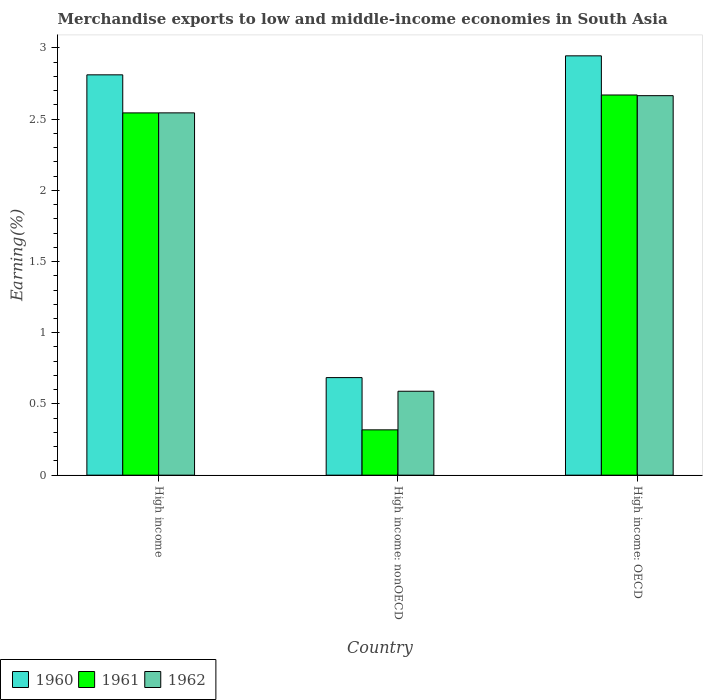How many groups of bars are there?
Your answer should be compact. 3. How many bars are there on the 2nd tick from the left?
Give a very brief answer. 3. How many bars are there on the 1st tick from the right?
Make the answer very short. 3. In how many cases, is the number of bars for a given country not equal to the number of legend labels?
Provide a short and direct response. 0. What is the percentage of amount earned from merchandise exports in 1960 in High income: nonOECD?
Make the answer very short. 0.69. Across all countries, what is the maximum percentage of amount earned from merchandise exports in 1960?
Give a very brief answer. 2.94. Across all countries, what is the minimum percentage of amount earned from merchandise exports in 1961?
Your response must be concise. 0.32. In which country was the percentage of amount earned from merchandise exports in 1960 maximum?
Provide a short and direct response. High income: OECD. In which country was the percentage of amount earned from merchandise exports in 1962 minimum?
Your answer should be compact. High income: nonOECD. What is the total percentage of amount earned from merchandise exports in 1962 in the graph?
Ensure brevity in your answer.  5.8. What is the difference between the percentage of amount earned from merchandise exports in 1962 in High income and that in High income: OECD?
Give a very brief answer. -0.12. What is the difference between the percentage of amount earned from merchandise exports in 1960 in High income and the percentage of amount earned from merchandise exports in 1961 in High income: OECD?
Ensure brevity in your answer.  0.14. What is the average percentage of amount earned from merchandise exports in 1962 per country?
Keep it short and to the point. 1.93. What is the difference between the percentage of amount earned from merchandise exports of/in 1962 and percentage of amount earned from merchandise exports of/in 1961 in High income: nonOECD?
Provide a succinct answer. 0.27. In how many countries, is the percentage of amount earned from merchandise exports in 1961 greater than 1 %?
Your response must be concise. 2. What is the ratio of the percentage of amount earned from merchandise exports in 1960 in High income: OECD to that in High income: nonOECD?
Your answer should be compact. 4.3. What is the difference between the highest and the second highest percentage of amount earned from merchandise exports in 1962?
Your answer should be very brief. -2.08. What is the difference between the highest and the lowest percentage of amount earned from merchandise exports in 1960?
Ensure brevity in your answer.  2.26. In how many countries, is the percentage of amount earned from merchandise exports in 1961 greater than the average percentage of amount earned from merchandise exports in 1961 taken over all countries?
Your answer should be very brief. 2. How many bars are there?
Offer a terse response. 9. Are all the bars in the graph horizontal?
Provide a short and direct response. No. Does the graph contain any zero values?
Keep it short and to the point. No. Does the graph contain grids?
Give a very brief answer. No. Where does the legend appear in the graph?
Offer a terse response. Bottom left. How many legend labels are there?
Your response must be concise. 3. What is the title of the graph?
Keep it short and to the point. Merchandise exports to low and middle-income economies in South Asia. What is the label or title of the Y-axis?
Give a very brief answer. Earning(%). What is the Earning(%) of 1960 in High income?
Provide a short and direct response. 2.81. What is the Earning(%) of 1961 in High income?
Provide a succinct answer. 2.54. What is the Earning(%) of 1962 in High income?
Ensure brevity in your answer.  2.54. What is the Earning(%) of 1960 in High income: nonOECD?
Offer a very short reply. 0.69. What is the Earning(%) in 1961 in High income: nonOECD?
Offer a very short reply. 0.32. What is the Earning(%) in 1962 in High income: nonOECD?
Offer a terse response. 0.59. What is the Earning(%) of 1960 in High income: OECD?
Provide a short and direct response. 2.94. What is the Earning(%) of 1961 in High income: OECD?
Provide a succinct answer. 2.67. What is the Earning(%) in 1962 in High income: OECD?
Your answer should be compact. 2.66. Across all countries, what is the maximum Earning(%) in 1960?
Provide a succinct answer. 2.94. Across all countries, what is the maximum Earning(%) of 1961?
Give a very brief answer. 2.67. Across all countries, what is the maximum Earning(%) of 1962?
Provide a succinct answer. 2.66. Across all countries, what is the minimum Earning(%) in 1960?
Provide a succinct answer. 0.69. Across all countries, what is the minimum Earning(%) in 1961?
Keep it short and to the point. 0.32. Across all countries, what is the minimum Earning(%) in 1962?
Provide a short and direct response. 0.59. What is the total Earning(%) in 1960 in the graph?
Your response must be concise. 6.44. What is the total Earning(%) of 1961 in the graph?
Your answer should be compact. 5.53. What is the total Earning(%) of 1962 in the graph?
Your answer should be very brief. 5.8. What is the difference between the Earning(%) of 1960 in High income and that in High income: nonOECD?
Provide a short and direct response. 2.13. What is the difference between the Earning(%) in 1961 in High income and that in High income: nonOECD?
Provide a short and direct response. 2.23. What is the difference between the Earning(%) in 1962 in High income and that in High income: nonOECD?
Make the answer very short. 1.95. What is the difference between the Earning(%) in 1960 in High income and that in High income: OECD?
Provide a succinct answer. -0.13. What is the difference between the Earning(%) in 1961 in High income and that in High income: OECD?
Provide a short and direct response. -0.13. What is the difference between the Earning(%) of 1962 in High income and that in High income: OECD?
Your answer should be compact. -0.12. What is the difference between the Earning(%) of 1960 in High income: nonOECD and that in High income: OECD?
Make the answer very short. -2.26. What is the difference between the Earning(%) of 1961 in High income: nonOECD and that in High income: OECD?
Your response must be concise. -2.35. What is the difference between the Earning(%) in 1962 in High income: nonOECD and that in High income: OECD?
Ensure brevity in your answer.  -2.08. What is the difference between the Earning(%) of 1960 in High income and the Earning(%) of 1961 in High income: nonOECD?
Your answer should be very brief. 2.49. What is the difference between the Earning(%) in 1960 in High income and the Earning(%) in 1962 in High income: nonOECD?
Offer a very short reply. 2.22. What is the difference between the Earning(%) in 1961 in High income and the Earning(%) in 1962 in High income: nonOECD?
Make the answer very short. 1.95. What is the difference between the Earning(%) in 1960 in High income and the Earning(%) in 1961 in High income: OECD?
Your response must be concise. 0.14. What is the difference between the Earning(%) of 1960 in High income and the Earning(%) of 1962 in High income: OECD?
Give a very brief answer. 0.15. What is the difference between the Earning(%) of 1961 in High income and the Earning(%) of 1962 in High income: OECD?
Your answer should be compact. -0.12. What is the difference between the Earning(%) of 1960 in High income: nonOECD and the Earning(%) of 1961 in High income: OECD?
Your answer should be compact. -1.98. What is the difference between the Earning(%) of 1960 in High income: nonOECD and the Earning(%) of 1962 in High income: OECD?
Your answer should be compact. -1.98. What is the difference between the Earning(%) of 1961 in High income: nonOECD and the Earning(%) of 1962 in High income: OECD?
Your answer should be very brief. -2.35. What is the average Earning(%) of 1960 per country?
Keep it short and to the point. 2.15. What is the average Earning(%) in 1961 per country?
Ensure brevity in your answer.  1.84. What is the average Earning(%) of 1962 per country?
Ensure brevity in your answer.  1.93. What is the difference between the Earning(%) of 1960 and Earning(%) of 1961 in High income?
Offer a very short reply. 0.27. What is the difference between the Earning(%) in 1960 and Earning(%) in 1962 in High income?
Make the answer very short. 0.27. What is the difference between the Earning(%) in 1961 and Earning(%) in 1962 in High income?
Give a very brief answer. -0. What is the difference between the Earning(%) of 1960 and Earning(%) of 1961 in High income: nonOECD?
Ensure brevity in your answer.  0.37. What is the difference between the Earning(%) in 1960 and Earning(%) in 1962 in High income: nonOECD?
Your answer should be very brief. 0.1. What is the difference between the Earning(%) in 1961 and Earning(%) in 1962 in High income: nonOECD?
Make the answer very short. -0.27. What is the difference between the Earning(%) in 1960 and Earning(%) in 1961 in High income: OECD?
Your answer should be very brief. 0.27. What is the difference between the Earning(%) in 1960 and Earning(%) in 1962 in High income: OECD?
Ensure brevity in your answer.  0.28. What is the difference between the Earning(%) in 1961 and Earning(%) in 1962 in High income: OECD?
Your answer should be compact. 0. What is the ratio of the Earning(%) in 1960 in High income to that in High income: nonOECD?
Keep it short and to the point. 4.1. What is the ratio of the Earning(%) of 1961 in High income to that in High income: nonOECD?
Provide a short and direct response. 8. What is the ratio of the Earning(%) in 1962 in High income to that in High income: nonOECD?
Your answer should be compact. 4.32. What is the ratio of the Earning(%) in 1960 in High income to that in High income: OECD?
Ensure brevity in your answer.  0.95. What is the ratio of the Earning(%) in 1961 in High income to that in High income: OECD?
Offer a terse response. 0.95. What is the ratio of the Earning(%) of 1962 in High income to that in High income: OECD?
Your response must be concise. 0.95. What is the ratio of the Earning(%) in 1960 in High income: nonOECD to that in High income: OECD?
Give a very brief answer. 0.23. What is the ratio of the Earning(%) of 1961 in High income: nonOECD to that in High income: OECD?
Provide a short and direct response. 0.12. What is the ratio of the Earning(%) in 1962 in High income: nonOECD to that in High income: OECD?
Offer a terse response. 0.22. What is the difference between the highest and the second highest Earning(%) of 1960?
Ensure brevity in your answer.  0.13. What is the difference between the highest and the second highest Earning(%) in 1961?
Ensure brevity in your answer.  0.13. What is the difference between the highest and the second highest Earning(%) in 1962?
Ensure brevity in your answer.  0.12. What is the difference between the highest and the lowest Earning(%) in 1960?
Your answer should be compact. 2.26. What is the difference between the highest and the lowest Earning(%) of 1961?
Provide a succinct answer. 2.35. What is the difference between the highest and the lowest Earning(%) of 1962?
Offer a very short reply. 2.08. 